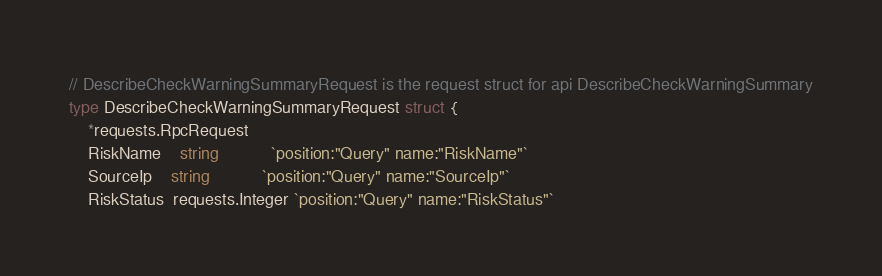Convert code to text. <code><loc_0><loc_0><loc_500><loc_500><_Go_>// DescribeCheckWarningSummaryRequest is the request struct for api DescribeCheckWarningSummary
type DescribeCheckWarningSummaryRequest struct {
	*requests.RpcRequest
	RiskName    string           `position:"Query" name:"RiskName"`
	SourceIp    string           `position:"Query" name:"SourceIp"`
	RiskStatus  requests.Integer `position:"Query" name:"RiskStatus"`</code> 